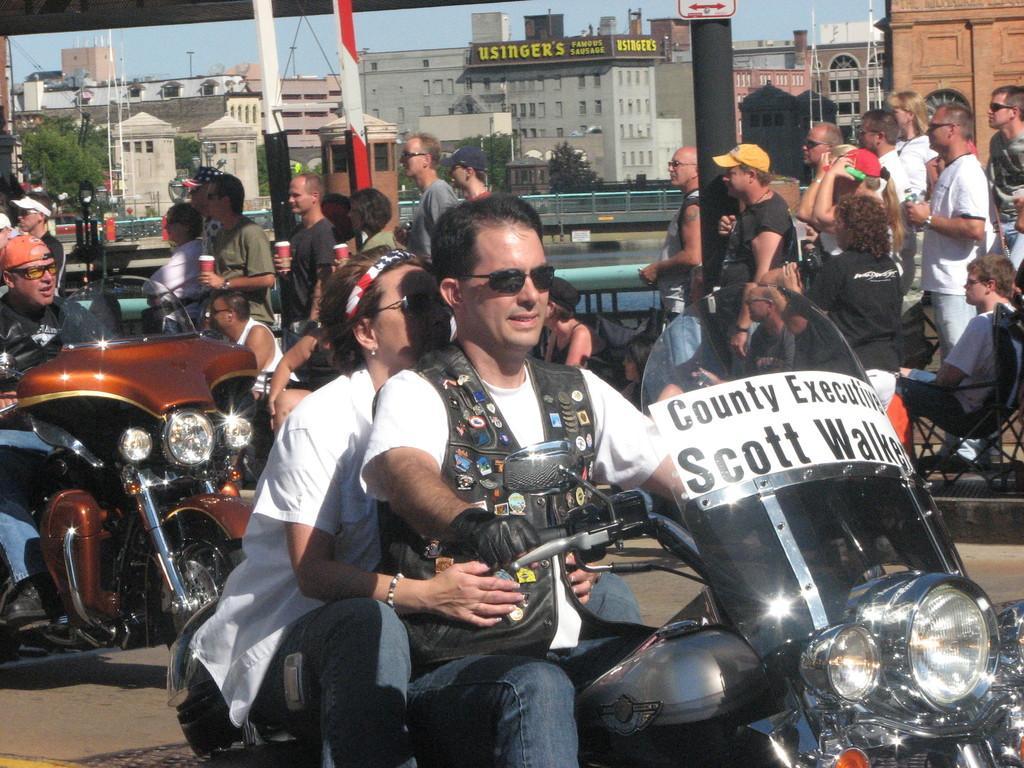In one or two sentences, can you explain what this image depicts? In this image i can see a man and woman riding bike on road at the back ground i can see few other people standing , car, and a building. 